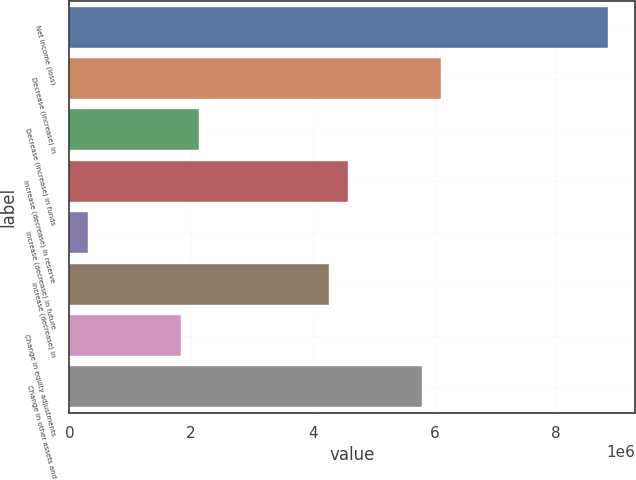Convert chart to OTSL. <chart><loc_0><loc_0><loc_500><loc_500><bar_chart><fcel>Net income (loss)<fcel>Decrease (increase) in<fcel>Decrease (increase) in funds<fcel>Increase (decrease) in reserve<fcel>Increase (decrease) in future<fcel>Increase (decrease) in<fcel>Change in equity adjustments<fcel>Change in other assets and<nl><fcel>8.84757e+06<fcel>6.10183e+06<fcel>2.13577e+06<fcel>4.57642e+06<fcel>305274<fcel>4.27134e+06<fcel>1.83068e+06<fcel>5.79675e+06<nl></chart> 